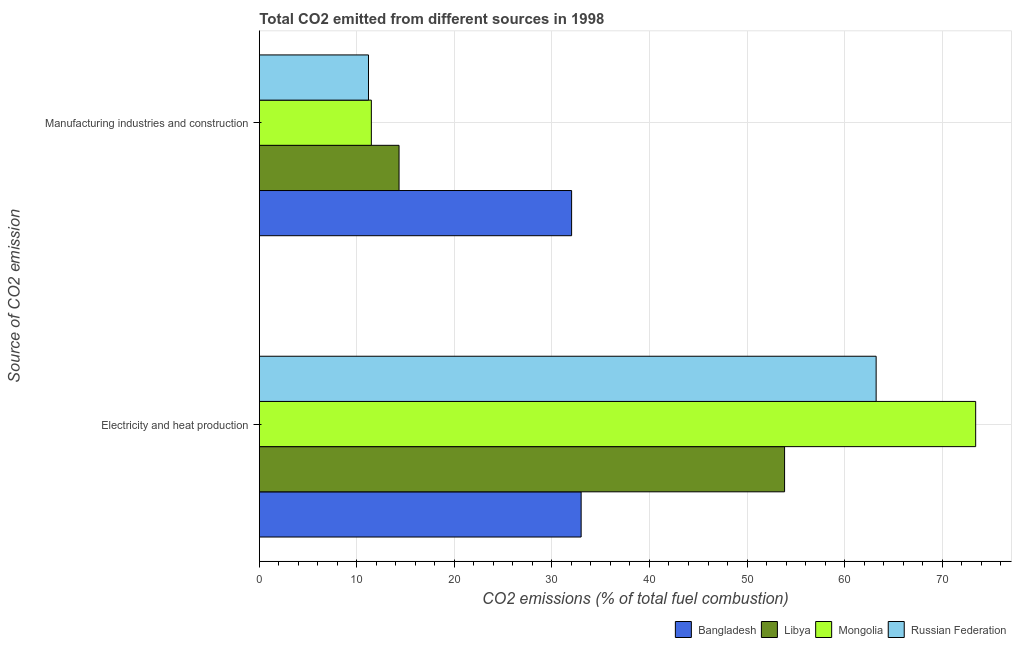How many groups of bars are there?
Make the answer very short. 2. Are the number of bars per tick equal to the number of legend labels?
Make the answer very short. Yes. How many bars are there on the 1st tick from the bottom?
Offer a very short reply. 4. What is the label of the 1st group of bars from the top?
Your response must be concise. Manufacturing industries and construction. What is the co2 emissions due to electricity and heat production in Libya?
Your response must be concise. 53.85. Across all countries, what is the maximum co2 emissions due to electricity and heat production?
Provide a short and direct response. 73.44. Across all countries, what is the minimum co2 emissions due to manufacturing industries?
Ensure brevity in your answer.  11.19. In which country was the co2 emissions due to electricity and heat production maximum?
Keep it short and to the point. Mongolia. In which country was the co2 emissions due to manufacturing industries minimum?
Your answer should be compact. Russian Federation. What is the total co2 emissions due to electricity and heat production in the graph?
Give a very brief answer. 223.53. What is the difference between the co2 emissions due to manufacturing industries in Mongolia and that in Bangladesh?
Offer a very short reply. -20.53. What is the difference between the co2 emissions due to manufacturing industries in Mongolia and the co2 emissions due to electricity and heat production in Bangladesh?
Ensure brevity in your answer.  -21.51. What is the average co2 emissions due to electricity and heat production per country?
Your answer should be compact. 55.88. What is the difference between the co2 emissions due to electricity and heat production and co2 emissions due to manufacturing industries in Mongolia?
Give a very brief answer. 61.96. What is the ratio of the co2 emissions due to electricity and heat production in Libya to that in Bangladesh?
Your response must be concise. 1.63. In how many countries, is the co2 emissions due to manufacturing industries greater than the average co2 emissions due to manufacturing industries taken over all countries?
Your answer should be compact. 1. What does the 1st bar from the top in Electricity and heat production represents?
Provide a short and direct response. Russian Federation. What does the 3rd bar from the bottom in Manufacturing industries and construction represents?
Offer a terse response. Mongolia. How many bars are there?
Offer a very short reply. 8. Are all the bars in the graph horizontal?
Your answer should be very brief. Yes. How many countries are there in the graph?
Give a very brief answer. 4. Are the values on the major ticks of X-axis written in scientific E-notation?
Offer a terse response. No. Where does the legend appear in the graph?
Offer a terse response. Bottom right. How many legend labels are there?
Provide a succinct answer. 4. What is the title of the graph?
Keep it short and to the point. Total CO2 emitted from different sources in 1998. What is the label or title of the X-axis?
Keep it short and to the point. CO2 emissions (% of total fuel combustion). What is the label or title of the Y-axis?
Provide a succinct answer. Source of CO2 emission. What is the CO2 emissions (% of total fuel combustion) of Bangladesh in Electricity and heat production?
Offer a very short reply. 32.99. What is the CO2 emissions (% of total fuel combustion) in Libya in Electricity and heat production?
Make the answer very short. 53.85. What is the CO2 emissions (% of total fuel combustion) of Mongolia in Electricity and heat production?
Offer a terse response. 73.44. What is the CO2 emissions (% of total fuel combustion) of Russian Federation in Electricity and heat production?
Offer a very short reply. 63.24. What is the CO2 emissions (% of total fuel combustion) of Bangladesh in Manufacturing industries and construction?
Provide a short and direct response. 32.02. What is the CO2 emissions (% of total fuel combustion) of Libya in Manufacturing industries and construction?
Ensure brevity in your answer.  14.32. What is the CO2 emissions (% of total fuel combustion) of Mongolia in Manufacturing industries and construction?
Offer a very short reply. 11.48. What is the CO2 emissions (% of total fuel combustion) of Russian Federation in Manufacturing industries and construction?
Make the answer very short. 11.19. Across all Source of CO2 emission, what is the maximum CO2 emissions (% of total fuel combustion) of Bangladesh?
Ensure brevity in your answer.  32.99. Across all Source of CO2 emission, what is the maximum CO2 emissions (% of total fuel combustion) in Libya?
Ensure brevity in your answer.  53.85. Across all Source of CO2 emission, what is the maximum CO2 emissions (% of total fuel combustion) in Mongolia?
Provide a short and direct response. 73.44. Across all Source of CO2 emission, what is the maximum CO2 emissions (% of total fuel combustion) of Russian Federation?
Make the answer very short. 63.24. Across all Source of CO2 emission, what is the minimum CO2 emissions (% of total fuel combustion) of Bangladesh?
Your answer should be very brief. 32.02. Across all Source of CO2 emission, what is the minimum CO2 emissions (% of total fuel combustion) of Libya?
Your answer should be compact. 14.32. Across all Source of CO2 emission, what is the minimum CO2 emissions (% of total fuel combustion) in Mongolia?
Your response must be concise. 11.48. Across all Source of CO2 emission, what is the minimum CO2 emissions (% of total fuel combustion) of Russian Federation?
Your answer should be compact. 11.19. What is the total CO2 emissions (% of total fuel combustion) in Bangladesh in the graph?
Keep it short and to the point. 65.01. What is the total CO2 emissions (% of total fuel combustion) in Libya in the graph?
Provide a succinct answer. 68.18. What is the total CO2 emissions (% of total fuel combustion) in Mongolia in the graph?
Ensure brevity in your answer.  84.93. What is the total CO2 emissions (% of total fuel combustion) in Russian Federation in the graph?
Your response must be concise. 74.43. What is the difference between the CO2 emissions (% of total fuel combustion) of Bangladesh in Electricity and heat production and that in Manufacturing industries and construction?
Make the answer very short. 0.98. What is the difference between the CO2 emissions (% of total fuel combustion) of Libya in Electricity and heat production and that in Manufacturing industries and construction?
Offer a very short reply. 39.53. What is the difference between the CO2 emissions (% of total fuel combustion) in Mongolia in Electricity and heat production and that in Manufacturing industries and construction?
Your response must be concise. 61.96. What is the difference between the CO2 emissions (% of total fuel combustion) in Russian Federation in Electricity and heat production and that in Manufacturing industries and construction?
Offer a terse response. 52.05. What is the difference between the CO2 emissions (% of total fuel combustion) in Bangladesh in Electricity and heat production and the CO2 emissions (% of total fuel combustion) in Libya in Manufacturing industries and construction?
Ensure brevity in your answer.  18.67. What is the difference between the CO2 emissions (% of total fuel combustion) of Bangladesh in Electricity and heat production and the CO2 emissions (% of total fuel combustion) of Mongolia in Manufacturing industries and construction?
Your answer should be compact. 21.51. What is the difference between the CO2 emissions (% of total fuel combustion) in Bangladesh in Electricity and heat production and the CO2 emissions (% of total fuel combustion) in Russian Federation in Manufacturing industries and construction?
Your response must be concise. 21.8. What is the difference between the CO2 emissions (% of total fuel combustion) of Libya in Electricity and heat production and the CO2 emissions (% of total fuel combustion) of Mongolia in Manufacturing industries and construction?
Your answer should be very brief. 42.37. What is the difference between the CO2 emissions (% of total fuel combustion) of Libya in Electricity and heat production and the CO2 emissions (% of total fuel combustion) of Russian Federation in Manufacturing industries and construction?
Provide a succinct answer. 42.66. What is the difference between the CO2 emissions (% of total fuel combustion) of Mongolia in Electricity and heat production and the CO2 emissions (% of total fuel combustion) of Russian Federation in Manufacturing industries and construction?
Ensure brevity in your answer.  62.26. What is the average CO2 emissions (% of total fuel combustion) in Bangladesh per Source of CO2 emission?
Give a very brief answer. 32.51. What is the average CO2 emissions (% of total fuel combustion) of Libya per Source of CO2 emission?
Give a very brief answer. 34.09. What is the average CO2 emissions (% of total fuel combustion) of Mongolia per Source of CO2 emission?
Offer a very short reply. 42.46. What is the average CO2 emissions (% of total fuel combustion) in Russian Federation per Source of CO2 emission?
Provide a succinct answer. 37.21. What is the difference between the CO2 emissions (% of total fuel combustion) in Bangladesh and CO2 emissions (% of total fuel combustion) in Libya in Electricity and heat production?
Offer a terse response. -20.86. What is the difference between the CO2 emissions (% of total fuel combustion) of Bangladesh and CO2 emissions (% of total fuel combustion) of Mongolia in Electricity and heat production?
Your answer should be very brief. -40.45. What is the difference between the CO2 emissions (% of total fuel combustion) of Bangladesh and CO2 emissions (% of total fuel combustion) of Russian Federation in Electricity and heat production?
Provide a succinct answer. -30.25. What is the difference between the CO2 emissions (% of total fuel combustion) in Libya and CO2 emissions (% of total fuel combustion) in Mongolia in Electricity and heat production?
Make the answer very short. -19.59. What is the difference between the CO2 emissions (% of total fuel combustion) of Libya and CO2 emissions (% of total fuel combustion) of Russian Federation in Electricity and heat production?
Give a very brief answer. -9.39. What is the difference between the CO2 emissions (% of total fuel combustion) of Mongolia and CO2 emissions (% of total fuel combustion) of Russian Federation in Electricity and heat production?
Give a very brief answer. 10.2. What is the difference between the CO2 emissions (% of total fuel combustion) in Bangladesh and CO2 emissions (% of total fuel combustion) in Libya in Manufacturing industries and construction?
Ensure brevity in your answer.  17.69. What is the difference between the CO2 emissions (% of total fuel combustion) in Bangladesh and CO2 emissions (% of total fuel combustion) in Mongolia in Manufacturing industries and construction?
Offer a very short reply. 20.53. What is the difference between the CO2 emissions (% of total fuel combustion) in Bangladesh and CO2 emissions (% of total fuel combustion) in Russian Federation in Manufacturing industries and construction?
Give a very brief answer. 20.83. What is the difference between the CO2 emissions (% of total fuel combustion) of Libya and CO2 emissions (% of total fuel combustion) of Mongolia in Manufacturing industries and construction?
Make the answer very short. 2.84. What is the difference between the CO2 emissions (% of total fuel combustion) in Libya and CO2 emissions (% of total fuel combustion) in Russian Federation in Manufacturing industries and construction?
Make the answer very short. 3.13. What is the difference between the CO2 emissions (% of total fuel combustion) in Mongolia and CO2 emissions (% of total fuel combustion) in Russian Federation in Manufacturing industries and construction?
Offer a terse response. 0.29. What is the ratio of the CO2 emissions (% of total fuel combustion) in Bangladesh in Electricity and heat production to that in Manufacturing industries and construction?
Offer a very short reply. 1.03. What is the ratio of the CO2 emissions (% of total fuel combustion) in Libya in Electricity and heat production to that in Manufacturing industries and construction?
Offer a very short reply. 3.76. What is the ratio of the CO2 emissions (% of total fuel combustion) of Mongolia in Electricity and heat production to that in Manufacturing industries and construction?
Keep it short and to the point. 6.4. What is the ratio of the CO2 emissions (% of total fuel combustion) of Russian Federation in Electricity and heat production to that in Manufacturing industries and construction?
Your answer should be compact. 5.65. What is the difference between the highest and the second highest CO2 emissions (% of total fuel combustion) of Bangladesh?
Offer a very short reply. 0.98. What is the difference between the highest and the second highest CO2 emissions (% of total fuel combustion) of Libya?
Offer a terse response. 39.53. What is the difference between the highest and the second highest CO2 emissions (% of total fuel combustion) of Mongolia?
Make the answer very short. 61.96. What is the difference between the highest and the second highest CO2 emissions (% of total fuel combustion) in Russian Federation?
Offer a very short reply. 52.05. What is the difference between the highest and the lowest CO2 emissions (% of total fuel combustion) in Bangladesh?
Your answer should be compact. 0.98. What is the difference between the highest and the lowest CO2 emissions (% of total fuel combustion) in Libya?
Keep it short and to the point. 39.53. What is the difference between the highest and the lowest CO2 emissions (% of total fuel combustion) of Mongolia?
Offer a very short reply. 61.96. What is the difference between the highest and the lowest CO2 emissions (% of total fuel combustion) of Russian Federation?
Keep it short and to the point. 52.05. 